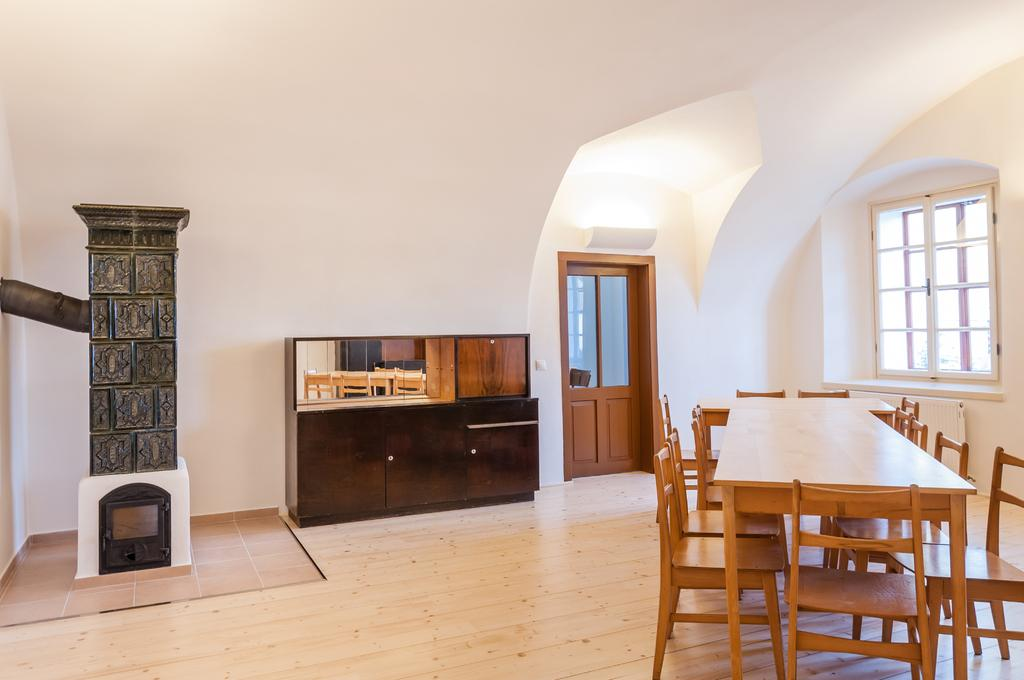Where is the setting of the image? The image is inside a room. What furniture is present in the room? There is a dining table and a cupboard in the room. What type of window is in the room? There is a glass window in the room. How can one enter or exit the room? There is a door in the room. Can you see any kitties playing on the farm in the image? There is no kitty or farm present in the image; it is set inside a room with a dining table, cupboard, glass window, and door. 